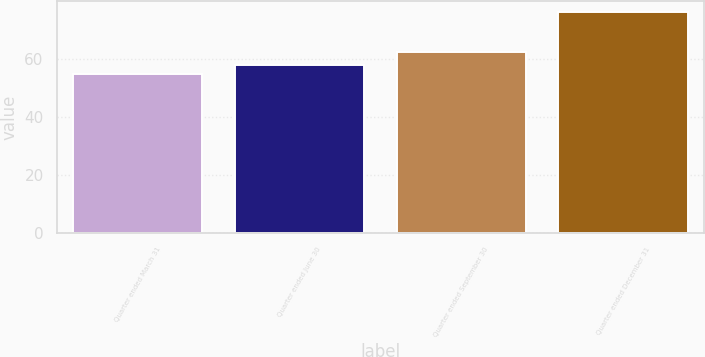Convert chart. <chart><loc_0><loc_0><loc_500><loc_500><bar_chart><fcel>Quarter ended March 31<fcel>Quarter ended June 30<fcel>Quarter ended September 30<fcel>Quarter ended December 31<nl><fcel>54.66<fcel>57.8<fcel>62.25<fcel>75.93<nl></chart> 